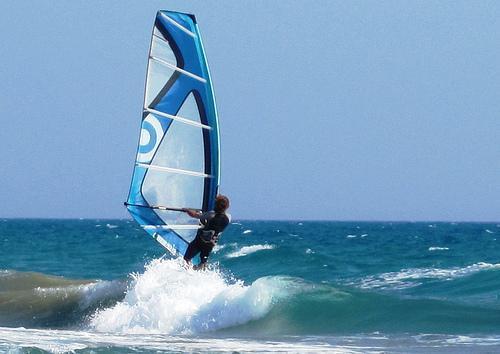How many people can you see?
Give a very brief answer. 1. 